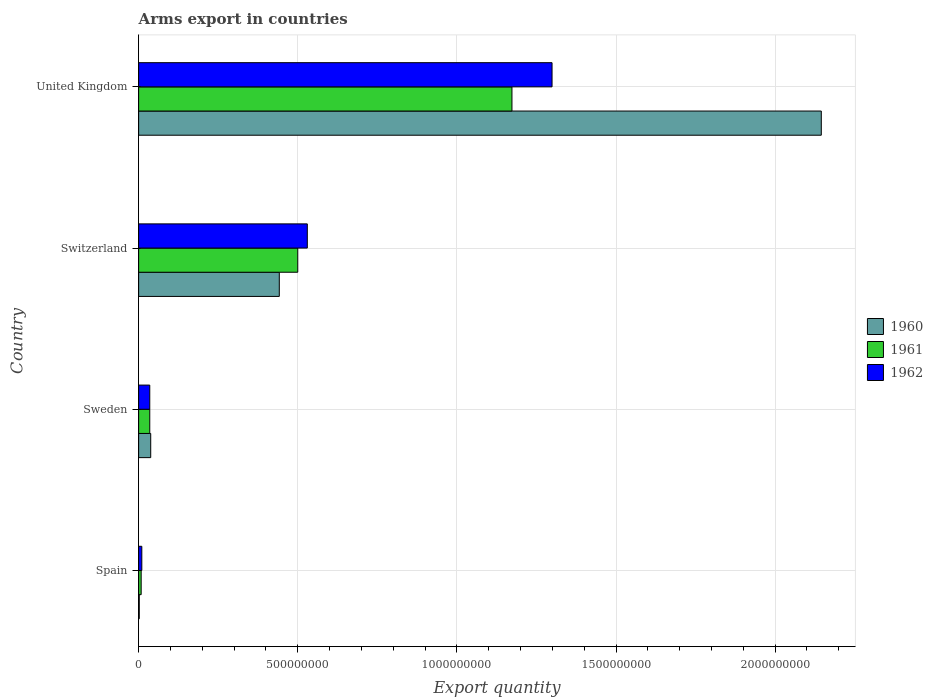How many different coloured bars are there?
Your answer should be very brief. 3. Are the number of bars on each tick of the Y-axis equal?
Ensure brevity in your answer.  Yes. How many bars are there on the 1st tick from the top?
Your answer should be compact. 3. What is the label of the 2nd group of bars from the top?
Give a very brief answer. Switzerland. What is the total arms export in 1961 in United Kingdom?
Offer a terse response. 1.17e+09. Across all countries, what is the maximum total arms export in 1960?
Offer a very short reply. 2.14e+09. In which country was the total arms export in 1961 maximum?
Provide a succinct answer. United Kingdom. What is the total total arms export in 1961 in the graph?
Give a very brief answer. 1.72e+09. What is the difference between the total arms export in 1962 in Sweden and that in Switzerland?
Give a very brief answer. -4.95e+08. What is the difference between the total arms export in 1962 in Switzerland and the total arms export in 1960 in Sweden?
Your response must be concise. 4.92e+08. What is the average total arms export in 1962 per country?
Provide a succinct answer. 4.68e+08. What is the difference between the total arms export in 1960 and total arms export in 1961 in Switzerland?
Your response must be concise. -5.80e+07. In how many countries, is the total arms export in 1962 greater than 2000000000 ?
Your answer should be compact. 0. What is the ratio of the total arms export in 1960 in Spain to that in United Kingdom?
Offer a very short reply. 0. Is the difference between the total arms export in 1960 in Spain and Switzerland greater than the difference between the total arms export in 1961 in Spain and Switzerland?
Your response must be concise. Yes. What is the difference between the highest and the second highest total arms export in 1962?
Your answer should be compact. 7.69e+08. What is the difference between the highest and the lowest total arms export in 1962?
Offer a very short reply. 1.29e+09. What does the 1st bar from the top in Switzerland represents?
Offer a very short reply. 1962. How many bars are there?
Provide a succinct answer. 12. Are all the bars in the graph horizontal?
Give a very brief answer. Yes. How many countries are there in the graph?
Give a very brief answer. 4. How are the legend labels stacked?
Your answer should be compact. Vertical. What is the title of the graph?
Your response must be concise. Arms export in countries. Does "1988" appear as one of the legend labels in the graph?
Your answer should be compact. No. What is the label or title of the X-axis?
Offer a terse response. Export quantity. What is the Export quantity of 1960 in Spain?
Provide a short and direct response. 2.00e+06. What is the Export quantity of 1960 in Sweden?
Provide a short and direct response. 3.80e+07. What is the Export quantity in 1961 in Sweden?
Your answer should be very brief. 3.50e+07. What is the Export quantity in 1962 in Sweden?
Provide a short and direct response. 3.50e+07. What is the Export quantity of 1960 in Switzerland?
Your answer should be very brief. 4.42e+08. What is the Export quantity in 1961 in Switzerland?
Your response must be concise. 5.00e+08. What is the Export quantity of 1962 in Switzerland?
Ensure brevity in your answer.  5.30e+08. What is the Export quantity of 1960 in United Kingdom?
Your answer should be compact. 2.14e+09. What is the Export quantity in 1961 in United Kingdom?
Provide a succinct answer. 1.17e+09. What is the Export quantity in 1962 in United Kingdom?
Offer a very short reply. 1.30e+09. Across all countries, what is the maximum Export quantity in 1960?
Offer a terse response. 2.14e+09. Across all countries, what is the maximum Export quantity of 1961?
Give a very brief answer. 1.17e+09. Across all countries, what is the maximum Export quantity of 1962?
Make the answer very short. 1.30e+09. Across all countries, what is the minimum Export quantity in 1960?
Offer a terse response. 2.00e+06. What is the total Export quantity in 1960 in the graph?
Your answer should be very brief. 2.63e+09. What is the total Export quantity in 1961 in the graph?
Provide a succinct answer. 1.72e+09. What is the total Export quantity of 1962 in the graph?
Offer a very short reply. 1.87e+09. What is the difference between the Export quantity of 1960 in Spain and that in Sweden?
Offer a very short reply. -3.60e+07. What is the difference between the Export quantity of 1961 in Spain and that in Sweden?
Give a very brief answer. -2.70e+07. What is the difference between the Export quantity in 1962 in Spain and that in Sweden?
Make the answer very short. -2.50e+07. What is the difference between the Export quantity of 1960 in Spain and that in Switzerland?
Offer a terse response. -4.40e+08. What is the difference between the Export quantity of 1961 in Spain and that in Switzerland?
Offer a very short reply. -4.92e+08. What is the difference between the Export quantity of 1962 in Spain and that in Switzerland?
Your answer should be very brief. -5.20e+08. What is the difference between the Export quantity of 1960 in Spain and that in United Kingdom?
Provide a short and direct response. -2.14e+09. What is the difference between the Export quantity in 1961 in Spain and that in United Kingdom?
Make the answer very short. -1.16e+09. What is the difference between the Export quantity of 1962 in Spain and that in United Kingdom?
Ensure brevity in your answer.  -1.29e+09. What is the difference between the Export quantity of 1960 in Sweden and that in Switzerland?
Offer a terse response. -4.04e+08. What is the difference between the Export quantity of 1961 in Sweden and that in Switzerland?
Your answer should be compact. -4.65e+08. What is the difference between the Export quantity in 1962 in Sweden and that in Switzerland?
Provide a succinct answer. -4.95e+08. What is the difference between the Export quantity of 1960 in Sweden and that in United Kingdom?
Ensure brevity in your answer.  -2.11e+09. What is the difference between the Export quantity of 1961 in Sweden and that in United Kingdom?
Keep it short and to the point. -1.14e+09. What is the difference between the Export quantity of 1962 in Sweden and that in United Kingdom?
Your answer should be compact. -1.26e+09. What is the difference between the Export quantity in 1960 in Switzerland and that in United Kingdom?
Offer a terse response. -1.70e+09. What is the difference between the Export quantity of 1961 in Switzerland and that in United Kingdom?
Offer a terse response. -6.73e+08. What is the difference between the Export quantity in 1962 in Switzerland and that in United Kingdom?
Offer a very short reply. -7.69e+08. What is the difference between the Export quantity in 1960 in Spain and the Export quantity in 1961 in Sweden?
Provide a succinct answer. -3.30e+07. What is the difference between the Export quantity in 1960 in Spain and the Export quantity in 1962 in Sweden?
Provide a succinct answer. -3.30e+07. What is the difference between the Export quantity of 1961 in Spain and the Export quantity of 1962 in Sweden?
Offer a very short reply. -2.70e+07. What is the difference between the Export quantity of 1960 in Spain and the Export quantity of 1961 in Switzerland?
Offer a terse response. -4.98e+08. What is the difference between the Export quantity in 1960 in Spain and the Export quantity in 1962 in Switzerland?
Make the answer very short. -5.28e+08. What is the difference between the Export quantity of 1961 in Spain and the Export quantity of 1962 in Switzerland?
Keep it short and to the point. -5.22e+08. What is the difference between the Export quantity of 1960 in Spain and the Export quantity of 1961 in United Kingdom?
Your answer should be compact. -1.17e+09. What is the difference between the Export quantity of 1960 in Spain and the Export quantity of 1962 in United Kingdom?
Offer a terse response. -1.30e+09. What is the difference between the Export quantity in 1961 in Spain and the Export quantity in 1962 in United Kingdom?
Your response must be concise. -1.29e+09. What is the difference between the Export quantity of 1960 in Sweden and the Export quantity of 1961 in Switzerland?
Your answer should be very brief. -4.62e+08. What is the difference between the Export quantity in 1960 in Sweden and the Export quantity in 1962 in Switzerland?
Provide a succinct answer. -4.92e+08. What is the difference between the Export quantity of 1961 in Sweden and the Export quantity of 1962 in Switzerland?
Make the answer very short. -4.95e+08. What is the difference between the Export quantity of 1960 in Sweden and the Export quantity of 1961 in United Kingdom?
Ensure brevity in your answer.  -1.14e+09. What is the difference between the Export quantity in 1960 in Sweden and the Export quantity in 1962 in United Kingdom?
Provide a short and direct response. -1.26e+09. What is the difference between the Export quantity of 1961 in Sweden and the Export quantity of 1962 in United Kingdom?
Ensure brevity in your answer.  -1.26e+09. What is the difference between the Export quantity of 1960 in Switzerland and the Export quantity of 1961 in United Kingdom?
Offer a very short reply. -7.31e+08. What is the difference between the Export quantity of 1960 in Switzerland and the Export quantity of 1962 in United Kingdom?
Offer a terse response. -8.57e+08. What is the difference between the Export quantity of 1961 in Switzerland and the Export quantity of 1962 in United Kingdom?
Your response must be concise. -7.99e+08. What is the average Export quantity of 1960 per country?
Your response must be concise. 6.57e+08. What is the average Export quantity in 1961 per country?
Your response must be concise. 4.29e+08. What is the average Export quantity in 1962 per country?
Ensure brevity in your answer.  4.68e+08. What is the difference between the Export quantity of 1960 and Export quantity of 1961 in Spain?
Give a very brief answer. -6.00e+06. What is the difference between the Export quantity of 1960 and Export quantity of 1962 in Spain?
Provide a short and direct response. -8.00e+06. What is the difference between the Export quantity in 1960 and Export quantity in 1962 in Sweden?
Your answer should be very brief. 3.00e+06. What is the difference between the Export quantity in 1961 and Export quantity in 1962 in Sweden?
Your answer should be very brief. 0. What is the difference between the Export quantity of 1960 and Export quantity of 1961 in Switzerland?
Offer a terse response. -5.80e+07. What is the difference between the Export quantity of 1960 and Export quantity of 1962 in Switzerland?
Your answer should be compact. -8.80e+07. What is the difference between the Export quantity in 1961 and Export quantity in 1962 in Switzerland?
Your answer should be very brief. -3.00e+07. What is the difference between the Export quantity of 1960 and Export quantity of 1961 in United Kingdom?
Your answer should be compact. 9.72e+08. What is the difference between the Export quantity of 1960 and Export quantity of 1962 in United Kingdom?
Your answer should be very brief. 8.46e+08. What is the difference between the Export quantity of 1961 and Export quantity of 1962 in United Kingdom?
Give a very brief answer. -1.26e+08. What is the ratio of the Export quantity of 1960 in Spain to that in Sweden?
Provide a short and direct response. 0.05. What is the ratio of the Export quantity of 1961 in Spain to that in Sweden?
Make the answer very short. 0.23. What is the ratio of the Export quantity in 1962 in Spain to that in Sweden?
Your answer should be very brief. 0.29. What is the ratio of the Export quantity of 1960 in Spain to that in Switzerland?
Offer a very short reply. 0. What is the ratio of the Export quantity in 1961 in Spain to that in Switzerland?
Provide a succinct answer. 0.02. What is the ratio of the Export quantity in 1962 in Spain to that in Switzerland?
Ensure brevity in your answer.  0.02. What is the ratio of the Export quantity of 1960 in Spain to that in United Kingdom?
Offer a terse response. 0. What is the ratio of the Export quantity in 1961 in Spain to that in United Kingdom?
Your response must be concise. 0.01. What is the ratio of the Export quantity of 1962 in Spain to that in United Kingdom?
Provide a succinct answer. 0.01. What is the ratio of the Export quantity in 1960 in Sweden to that in Switzerland?
Offer a terse response. 0.09. What is the ratio of the Export quantity of 1961 in Sweden to that in Switzerland?
Offer a very short reply. 0.07. What is the ratio of the Export quantity in 1962 in Sweden to that in Switzerland?
Your answer should be compact. 0.07. What is the ratio of the Export quantity of 1960 in Sweden to that in United Kingdom?
Provide a short and direct response. 0.02. What is the ratio of the Export quantity in 1961 in Sweden to that in United Kingdom?
Offer a terse response. 0.03. What is the ratio of the Export quantity of 1962 in Sweden to that in United Kingdom?
Provide a succinct answer. 0.03. What is the ratio of the Export quantity of 1960 in Switzerland to that in United Kingdom?
Your answer should be very brief. 0.21. What is the ratio of the Export quantity of 1961 in Switzerland to that in United Kingdom?
Keep it short and to the point. 0.43. What is the ratio of the Export quantity in 1962 in Switzerland to that in United Kingdom?
Your answer should be very brief. 0.41. What is the difference between the highest and the second highest Export quantity of 1960?
Offer a terse response. 1.70e+09. What is the difference between the highest and the second highest Export quantity of 1961?
Keep it short and to the point. 6.73e+08. What is the difference between the highest and the second highest Export quantity in 1962?
Ensure brevity in your answer.  7.69e+08. What is the difference between the highest and the lowest Export quantity of 1960?
Your answer should be compact. 2.14e+09. What is the difference between the highest and the lowest Export quantity in 1961?
Your answer should be very brief. 1.16e+09. What is the difference between the highest and the lowest Export quantity of 1962?
Your answer should be compact. 1.29e+09. 